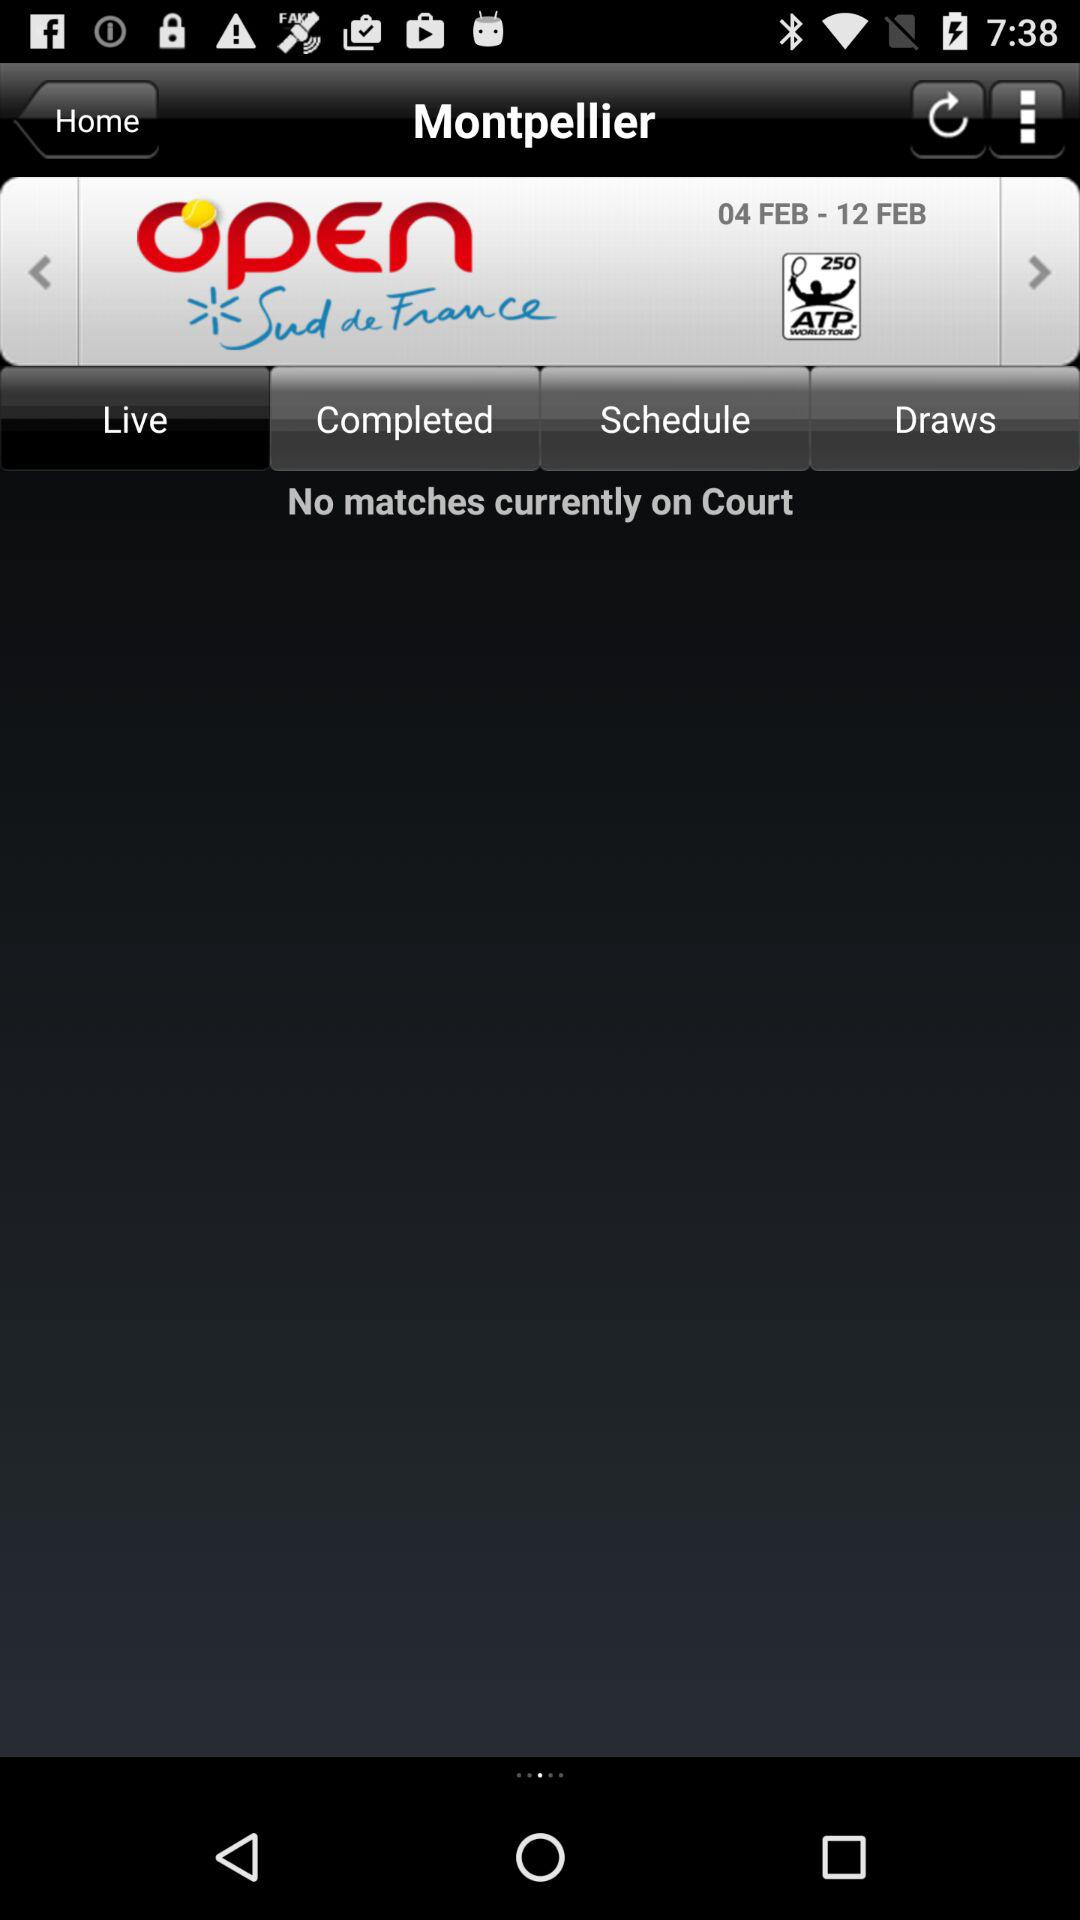What is the date range? The date range is from February 4 to February 12. 